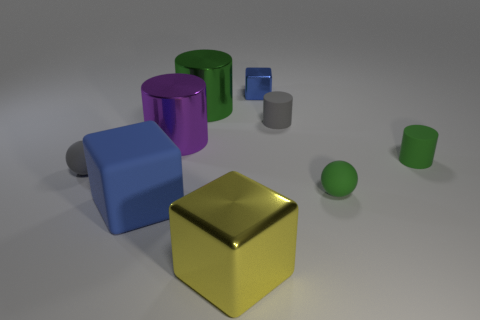Subtract all red blocks. How many green cylinders are left? 2 Subtract all small cubes. How many cubes are left? 2 Subtract all purple cylinders. How many cylinders are left? 3 Subtract 2 cylinders. How many cylinders are left? 2 Add 1 green cylinders. How many objects exist? 10 Subtract all red cylinders. Subtract all yellow balls. How many cylinders are left? 4 Subtract all cubes. How many objects are left? 6 Subtract all big shiny objects. Subtract all green shiny blocks. How many objects are left? 6 Add 4 large yellow things. How many large yellow things are left? 5 Add 6 gray matte things. How many gray matte things exist? 8 